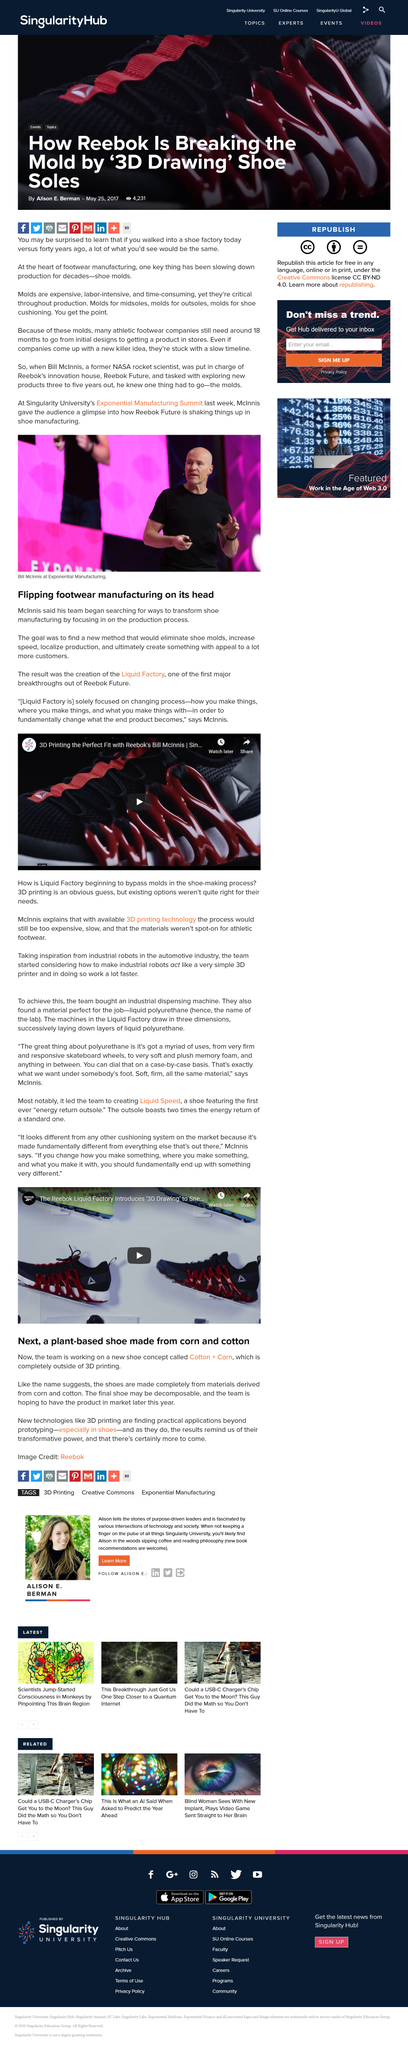Specify some key components in this picture. Reebok Future Labs is the name of Reebok's innovation house. The McInnis' team focused on transforming shoe manufacturing by transforming the production process. The final shoe produced through the cotton+corn process may be decomposable, featuring a unique combination of cotton and corn-based materials that provide both sustainability and durability. Liquid Factory is solely dedicated to transforming the way we manufacture goods by focusing on process, location, and materials. Reebok's first major breakthrough was the launch of Liquid Factory, which revolutionized the fitness industry by combining cutting-edge technology with innovative design. This groundbreaking product paved the way for future Reebok success and set the standard for high-performance footwear. 